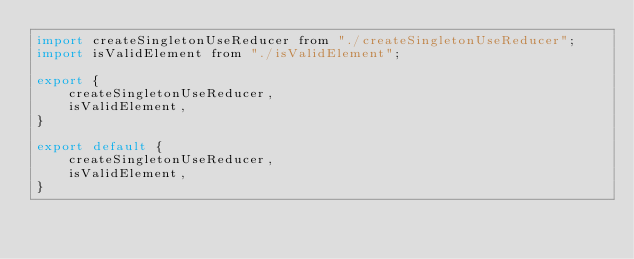Convert code to text. <code><loc_0><loc_0><loc_500><loc_500><_JavaScript_>import createSingletonUseReducer from "./createSingletonUseReducer";
import isValidElement from "./isValidElement";

export {
    createSingletonUseReducer,
    isValidElement,
}

export default {
    createSingletonUseReducer,
    isValidElement,
}
</code> 